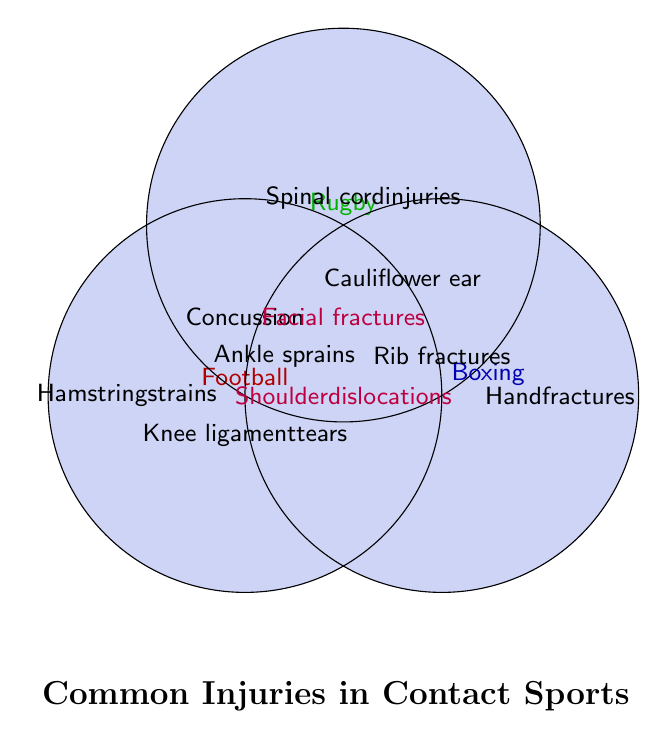What's the title of the figure? The title is typically found at the top or bottom of a figure. In this case, it's located at the bottom.
Answer: Common Injuries in Contact Sports Which injuries are common in all three sports (Football, Rugby, and Boxing)? The overlapping section of all three circles (Football, Rugby, Boxing) indicates the injuries common to all these sports.
Answer: Facial fractures, Shoulder dislocations What injuries are unique to Football? The area solely within the Football circle but outside any overlap with Rugby or Boxing indicates injuries unique to Football.
Answer: Hamstring strains How many types of injuries are shown in the intersection between Rugby and Boxing? The overlapping area between the Rugby and Boxing circles shows injuries common to both sports, excluding Football.
Answer: Two (Cauliflower ear, Rib fractures) Which sport has the highest unique injury mentioned? Look at the non-overlapping areas of each circle to identify the unique injury mentioned for each sport. Compare the count.
Answer: None (each has one) Which injuries are shared between Football and Rugby but not with Boxing? Reference the overlapping area between the Football and Rugby circles, excluding any part overlapping with Boxing.
Answer: Concussion, Knee ligament tears, Ankle sprains Identify the injury types mentioned in Rugby but not in any other sport. Look solely within the Rugby circle where there's no overlap with Football or Boxing.
Answer: Spinal cord injuries What injuries are shared between all three sports and mention two specific ones? Refer to the central area where all three circles overlap for injuries common to all three sports and list two specific injuries.
Answer: Facial fractures, Shoulder dislocations 